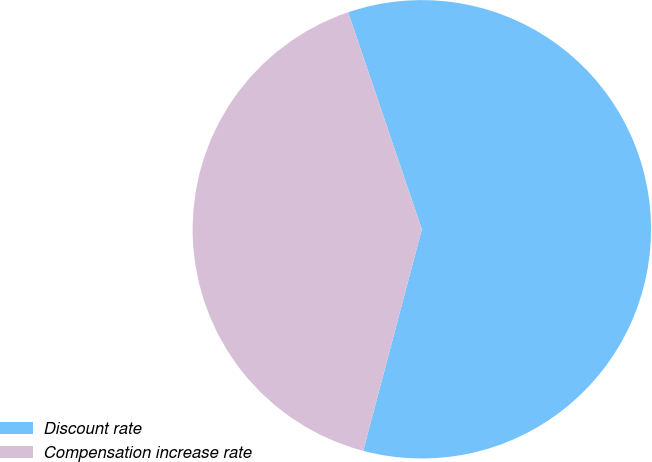Convert chart to OTSL. <chart><loc_0><loc_0><loc_500><loc_500><pie_chart><fcel>Discount rate<fcel>Compensation increase rate<nl><fcel>59.33%<fcel>40.67%<nl></chart> 